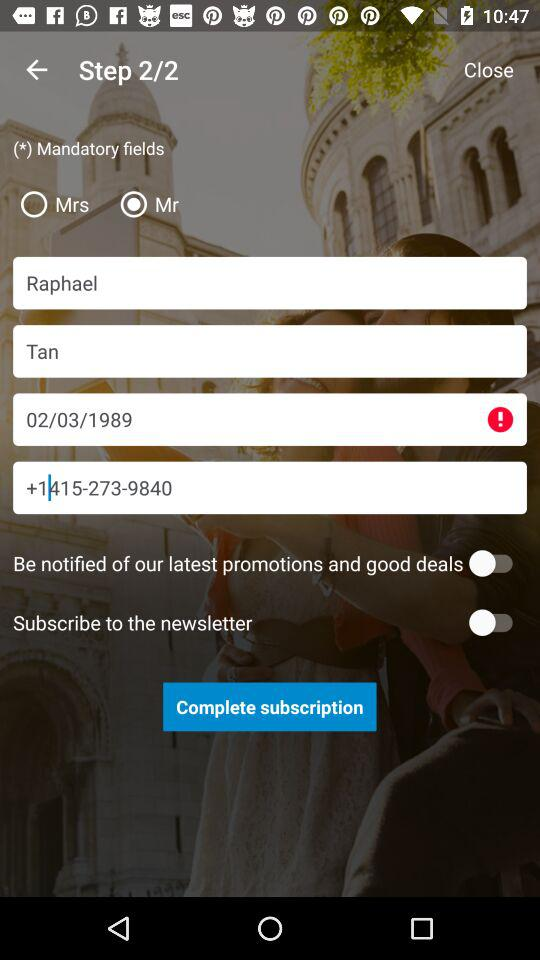What is the phone number? The phone number is +1415-273-9840. 